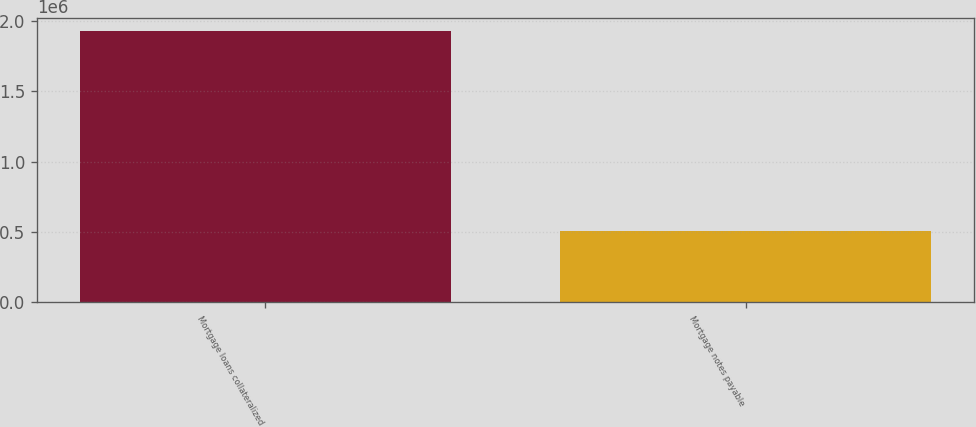<chart> <loc_0><loc_0><loc_500><loc_500><bar_chart><fcel>Mortgage loans collateralized<fcel>Mortgage notes payable<nl><fcel>1.92773e+06<fcel>508547<nl></chart> 